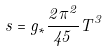Convert formula to latex. <formula><loc_0><loc_0><loc_500><loc_500>s = g _ { \ast } \frac { 2 \pi ^ { 2 } } { 4 5 } T ^ { 3 }</formula> 